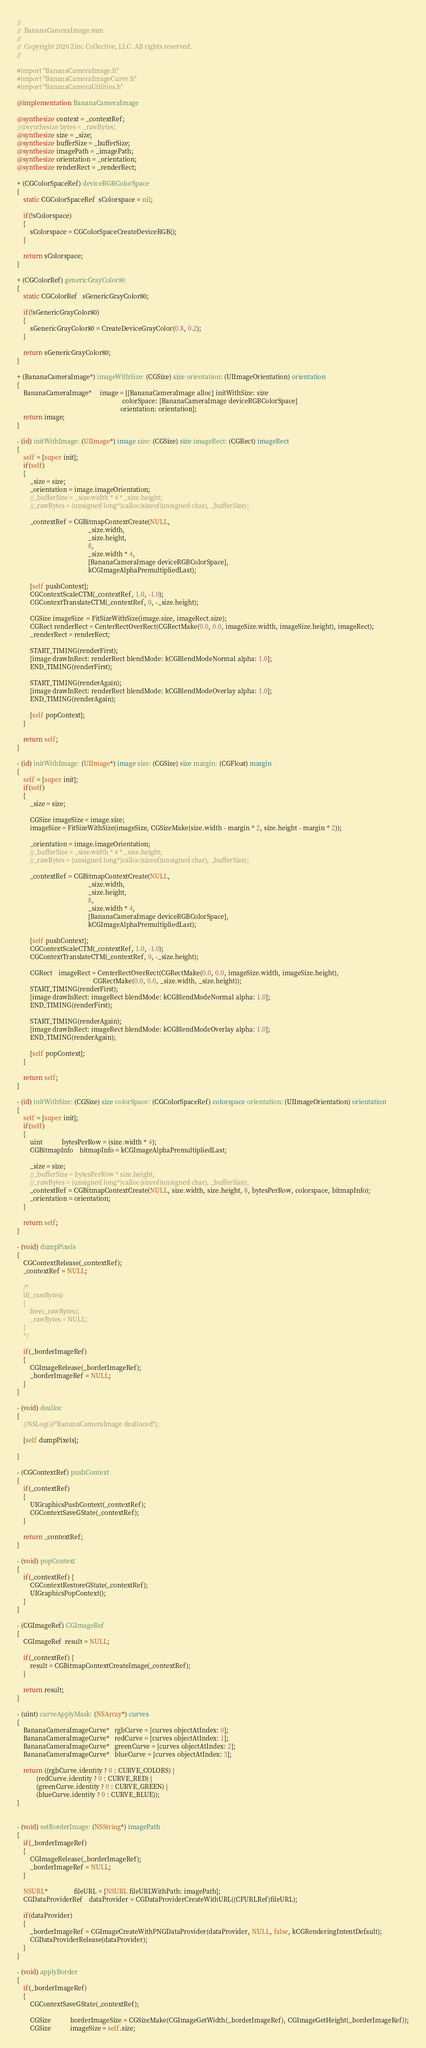<code> <loc_0><loc_0><loc_500><loc_500><_ObjectiveC_>//
//  BananaCameraImage.mm
//
//  Copyright 2020 Zinc Collective, LLC. All rights reserved.
//

#import "BananaCameraImage.h"
#import "BananaCameraImageCurve.h"
#import "BananaCameraUtilities.h"

@implementation BananaCameraImage

@synthesize context = _contextRef;
//@synthesize bytes = _rawBytes;
@synthesize size = _size;
@synthesize bufferSize = _bufferSize;
@synthesize imagePath = _imagePath;
@synthesize orientation = _orientation;
@synthesize renderRect = _renderRect;

+ (CGColorSpaceRef) deviceRGBColorSpace
{
    static CGColorSpaceRef  sColorspace = nil;
    
    if(!sColorspace)
    {
        sColorspace = CGColorSpaceCreateDeviceRGB();
    }
    
    return sColorspace;
}

+ (CGColorRef) genericGrayColor80
{
    static CGColorRef   sGenericGrayColor80;
    
    if(!sGenericGrayColor80)
    {
        sGenericGrayColor80 = CreateDeviceGrayColor(0.8, 0.2);
    }
    
    return sGenericGrayColor80;
}

+ (BananaCameraImage*) imageWithSize: (CGSize) size orientation: (UIImageOrientation) orientation
{
    BananaCameraImage*     image = [[BananaCameraImage alloc] initWithSize: size 
																 colorSpace: [BananaCameraImage deviceRGBColorSpace]
																orientation: orientation];
    return image;
}

- (id) initWithImage: (UIImage*) image size: (CGSize) size imageRect: (CGRect) imageRect
{
	self = [super init];
	if(self)
	{
		_size = size;
		_orientation = image.imageOrientation;
        //_bufferSize = _size.width * 4 * _size.height;
        //_rawBytes = (unsigned long*)calloc(sizeof(unsigned char), _bufferSize);
		
        _contextRef = CGBitmapContextCreate(NULL,
											_size.width, 
											_size.height, 
											8, 
											_size.width * 4, 
											[BananaCameraImage deviceRGBColorSpace], 
											kCGImageAlphaPremultipliedLast);
		
		[self pushContext];
		CGContextScaleCTM(_contextRef, 1.0, -1.0);
		CGContextTranslateCTM(_contextRef, 0, -_size.height);

		CGSize imageSize  = FitSizeWithSize(image.size, imageRect.size);
		CGRect renderRect = CenterRectOverRect(CGRectMake(0.0, 0.0, imageSize.width, imageSize.height), imageRect);
		_renderRect = renderRect;
        
		START_TIMING(renderFirst);
		[image drawInRect: renderRect blendMode: kCGBlendModeNormal alpha: 1.0];
		END_TIMING(renderFirst);
		
		START_TIMING(renderAgain);
		[image drawInRect: renderRect blendMode: kCGBlendModeOverlay alpha: 1.0];
		END_TIMING(renderAgain);		
		
        [self popContext];
	}
	
	return self;
}

- (id) initWithImage: (UIImage*) image size: (CGSize) size margin: (CGFloat) margin
{
	self = [super init];
	if(self)
	{
		_size = size;
		
		CGSize imageSize = image.size;
		imageSize = FitSizeWithSize(imageSize, CGSizeMake(size.width - margin * 2, size.height - margin * 2));
		
		_orientation = image.imageOrientation;
        //_bufferSize = _size.width * 4 * _size.height;
        //_rawBytes = (unsigned long*)calloc(sizeof(unsigned char), _bufferSize);
		
        _contextRef = CGBitmapContextCreate(NULL,
											_size.width, 
											_size.height, 
											8, 
											_size.width * 4, 
											[BananaCameraImage deviceRGBColorSpace], 
											kCGImageAlphaPremultipliedLast);
		
		[self pushContext];
		CGContextScaleCTM(_contextRef, 1.0, -1.0);
		CGContextTranslateCTM(_contextRef, 0, -_size.height);
		
		CGRect	imageRect = CenterRectOverRect(CGRectMake(0.0, 0.0, imageSize.width, imageSize.height), 
											   CGRectMake(0.0, 0.0, _size.width, _size.height));
		START_TIMING(renderFirst);
		[image drawInRect: imageRect blendMode: kCGBlendModeNormal alpha: 1.0];
		END_TIMING(renderFirst);

		START_TIMING(renderAgain);
		[image drawInRect: imageRect blendMode: kCGBlendModeOverlay alpha: 1.0];
		END_TIMING(renderAgain);		
		
		[self popContext];		
	}
	
	return self;
}

- (id) initWithSize: (CGSize) size colorSpace: (CGColorSpaceRef) colorspace orientation: (UIImageOrientation) orientation
{
    self = [super init];
    if(self)
    {
        uint            bytesPerRow = (size.width * 4);
        CGBitmapInfo    bitmapInfo = kCGImageAlphaPremultipliedLast;

        _size = size;
        //_bufferSize = bytesPerRow * size.height;
        //_rawBytes = (unsigned long*)calloc(sizeof(unsigned char), _bufferSize);
        _contextRef = CGBitmapContextCreate(NULL, size.width, size.height, 8, bytesPerRow, colorspace, bitmapInfo);
		_orientation = orientation;
    }
    
    return self;
}

- (void) dumpPixels
{
    CGContextRelease(_contextRef);
    _contextRef = NULL;
   
    /*
	if(_rawBytes)
	{
		free(_rawBytes);
		_rawBytes = NULL;
	}
    */
	
	if(_borderImageRef)
	{
		CGImageRelease(_borderImageRef);
		_borderImageRef = NULL;
	}
}

- (void) dealloc
{
	//NSLog(@"BananaCameraImage dealloced");
	
	[self dumpPixels];
	
}

- (CGContextRef) pushContext
{
    if(_contextRef)
    {
        UIGraphicsPushContext(_contextRef);
        CGContextSaveGState(_contextRef);
    }
    
    return _contextRef;
}

- (void) popContext
{
    if(_contextRef) {
        CGContextRestoreGState(_contextRef);
        UIGraphicsPopContext();
    }
}

- (CGImageRef) CGImageRef
{
    CGImageRef  result = NULL;
    
    if(_contextRef) {
        result = CGBitmapContextCreateImage(_contextRef);
    }
    
    return result;
}

- (uint) curveApplyMask: (NSArray*) curves
{
    BananaCameraImageCurve*   rgbCurve = [curves objectAtIndex: 0];
    BananaCameraImageCurve*   redCurve = [curves objectAtIndex: 1];
    BananaCameraImageCurve*   greenCurve = [curves objectAtIndex: 2];
    BananaCameraImageCurve*   blueCurve = [curves objectAtIndex: 3];
    
    return ((rgbCurve.identity ? 0 : CURVE_COLORS) |
            (redCurve.identity ? 0 : CURVE_RED) |
            (greenCurve.identity ? 0 : CURVE_GREEN) |
            (blueCurve.identity ? 0 : CURVE_BLUE));
}


- (void) setBorderImage: (NSString*) imagePath
{
	if(_borderImageRef)
	{
		CGImageRelease(_borderImageRef);
		_borderImageRef = NULL;
	}
	
	NSURL*				fileURL = [NSURL fileURLWithPath: imagePath];
	CGDataProviderRef	dataProvider = CGDataProviderCreateWithURL((CFURLRef)fileURL);

	if(dataProvider)
	{
		_borderImageRef = CGImageCreateWithPNGDataProvider(dataProvider, NULL, false, kCGRenderingIntentDefault);
		CGDataProviderRelease(dataProvider);
	}
}

- (void) applyBorder
{
	if(_borderImageRef)
	{
		CGContextSaveGState(_contextRef);

		CGSize			borderImageSize = CGSizeMake(CGImageGetWidth(_borderImageRef), CGImageGetHeight(_borderImageRef));
		CGSize			imageSize = self.size;</code> 